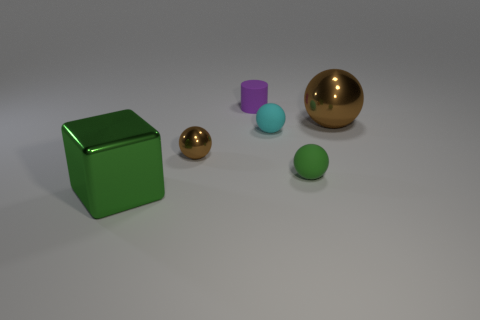Does the tiny cyan object have the same material as the tiny thing to the left of the small cylinder?
Make the answer very short. No. There is a large block; is its color the same as the small matte sphere in front of the cyan matte sphere?
Ensure brevity in your answer.  Yes. There is a rubber ball that is the same color as the metal cube; what is its size?
Offer a very short reply. Small. There is a tiny object that is the same color as the big sphere; what is it made of?
Your answer should be compact. Metal. Are there any objects of the same color as the metallic block?
Keep it short and to the point. Yes. Is there a tiny thing that has the same material as the small brown ball?
Offer a terse response. No. What number of brown spheres are left of the tiny rubber cylinder and on the right side of the green matte thing?
Keep it short and to the point. 0. Are there fewer tiny cyan objects that are to the left of the green metallic cube than brown metal things that are in front of the big sphere?
Your response must be concise. Yes. Is the large brown object the same shape as the cyan rubber object?
Offer a very short reply. Yes. What number of other objects are the same size as the green metallic object?
Your answer should be compact. 1. 